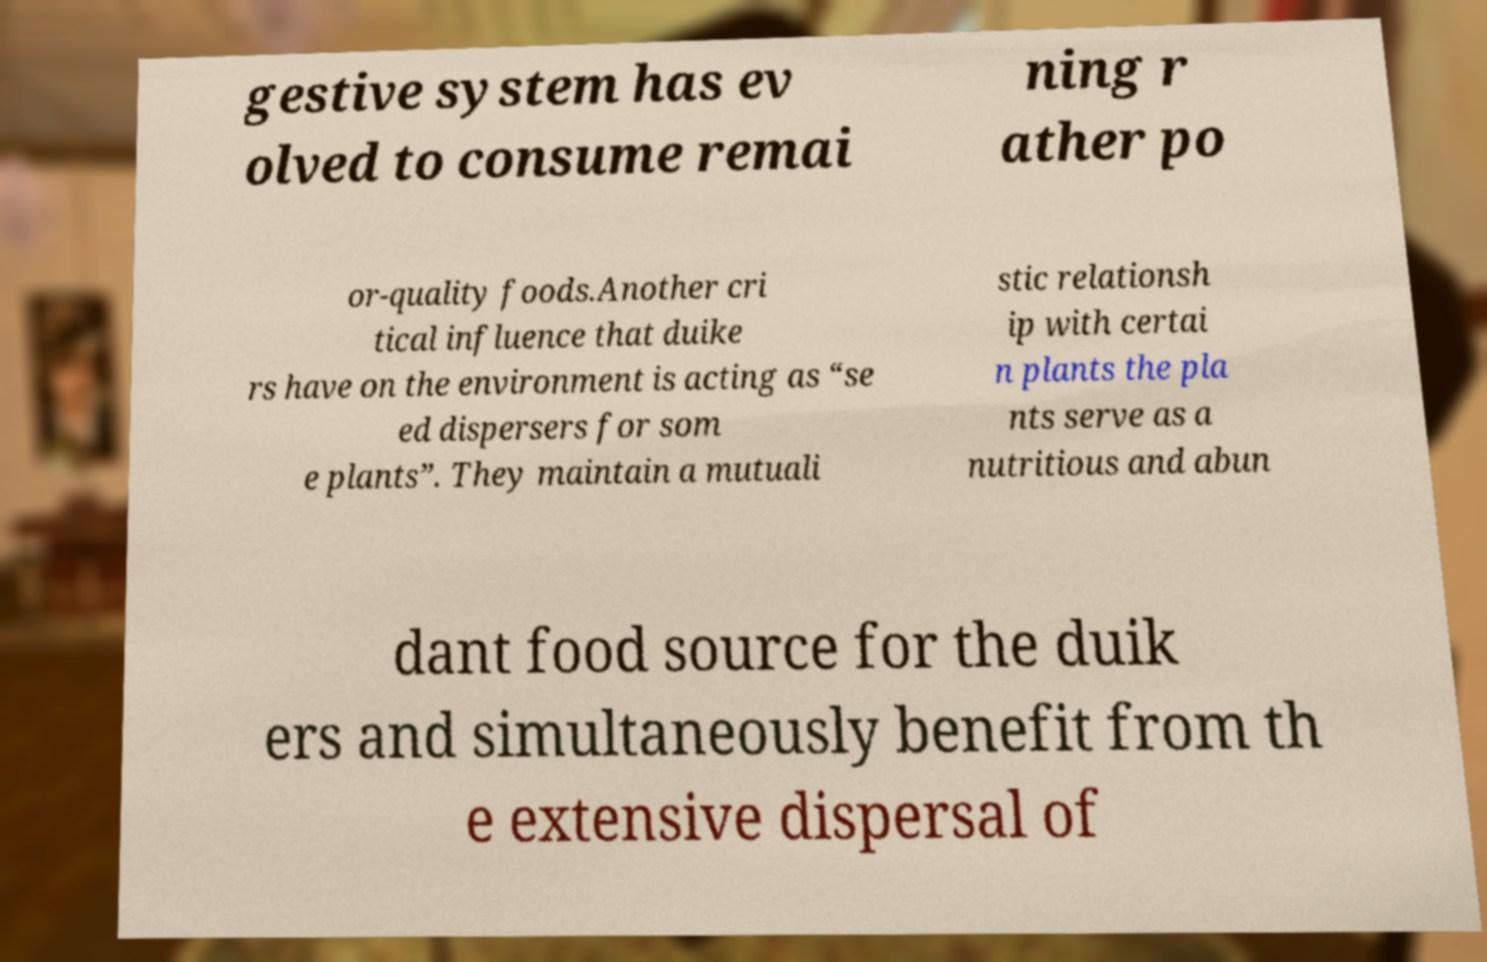Please read and relay the text visible in this image. What does it say? gestive system has ev olved to consume remai ning r ather po or-quality foods.Another cri tical influence that duike rs have on the environment is acting as “se ed dispersers for som e plants”. They maintain a mutuali stic relationsh ip with certai n plants the pla nts serve as a nutritious and abun dant food source for the duik ers and simultaneously benefit from th e extensive dispersal of 